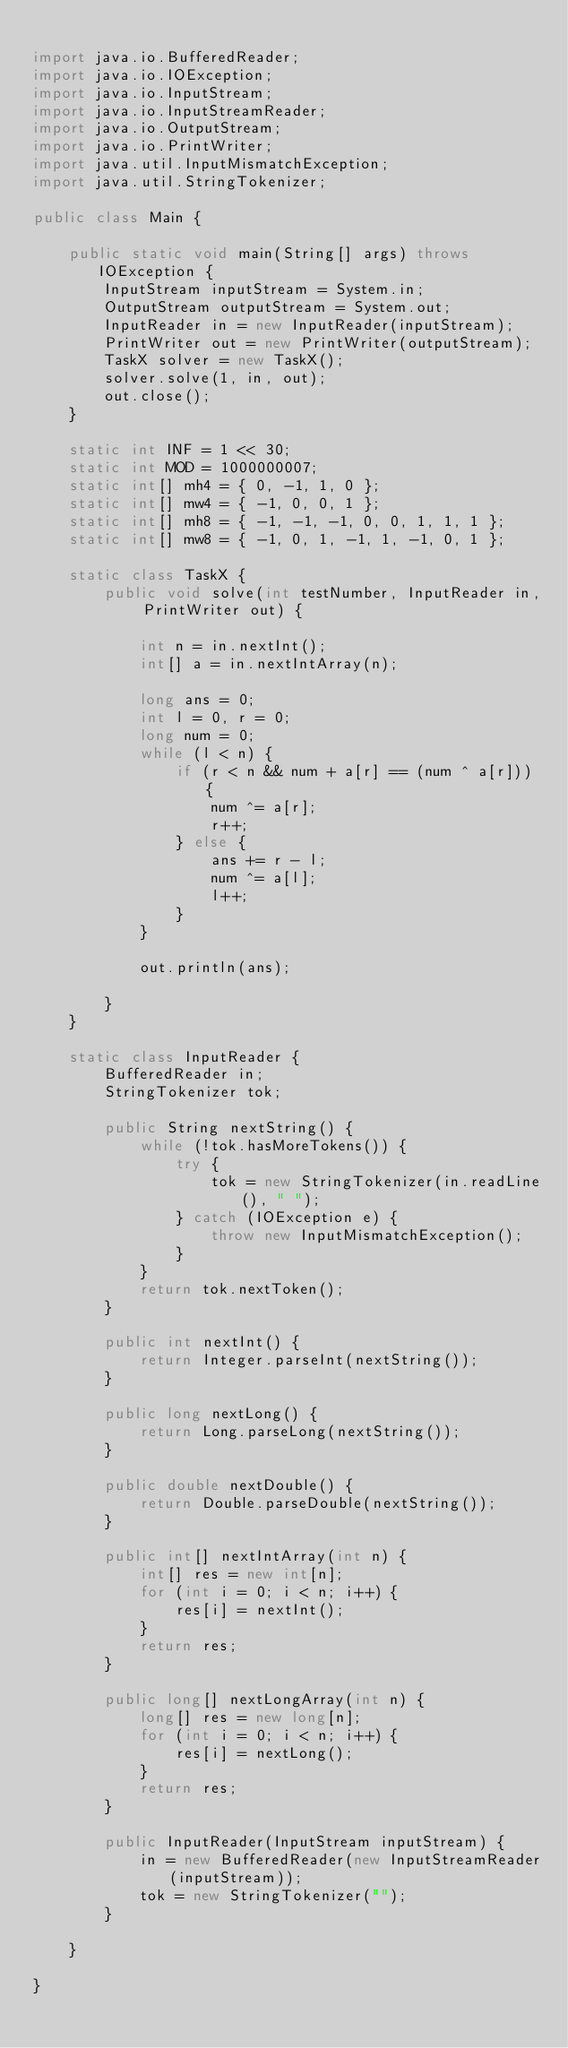<code> <loc_0><loc_0><loc_500><loc_500><_Java_>
import java.io.BufferedReader;
import java.io.IOException;
import java.io.InputStream;
import java.io.InputStreamReader;
import java.io.OutputStream;
import java.io.PrintWriter;
import java.util.InputMismatchException;
import java.util.StringTokenizer;

public class Main {

	public static void main(String[] args) throws IOException {
		InputStream inputStream = System.in;
		OutputStream outputStream = System.out;
		InputReader in = new InputReader(inputStream);
		PrintWriter out = new PrintWriter(outputStream);
		TaskX solver = new TaskX();
		solver.solve(1, in, out);
		out.close();
	}

	static int INF = 1 << 30;
	static int MOD = 1000000007;
	static int[] mh4 = { 0, -1, 1, 0 };
	static int[] mw4 = { -1, 0, 0, 1 };
	static int[] mh8 = { -1, -1, -1, 0, 0, 1, 1, 1 };
	static int[] mw8 = { -1, 0, 1, -1, 1, -1, 0, 1 };

	static class TaskX {
		public void solve(int testNumber, InputReader in, PrintWriter out) {

			int n = in.nextInt();
			int[] a = in.nextIntArray(n);

			long ans = 0;
			int l = 0, r = 0;
			long num = 0;
			while (l < n) {
				if (r < n && num + a[r] == (num ^ a[r])) {
					num ^= a[r];
					r++;
				} else {
					ans += r - l;
					num ^= a[l];
					l++;
				}
			}

			out.println(ans);

		}
	}

	static class InputReader {
		BufferedReader in;
		StringTokenizer tok;

		public String nextString() {
			while (!tok.hasMoreTokens()) {
				try {
					tok = new StringTokenizer(in.readLine(), " ");
				} catch (IOException e) {
					throw new InputMismatchException();
				}
			}
			return tok.nextToken();
		}

		public int nextInt() {
			return Integer.parseInt(nextString());
		}

		public long nextLong() {
			return Long.parseLong(nextString());
		}

		public double nextDouble() {
			return Double.parseDouble(nextString());
		}

		public int[] nextIntArray(int n) {
			int[] res = new int[n];
			for (int i = 0; i < n; i++) {
				res[i] = nextInt();
			}
			return res;
		}

		public long[] nextLongArray(int n) {
			long[] res = new long[n];
			for (int i = 0; i < n; i++) {
				res[i] = nextLong();
			}
			return res;
		}

		public InputReader(InputStream inputStream) {
			in = new BufferedReader(new InputStreamReader(inputStream));
			tok = new StringTokenizer("");
		}

	}

}
</code> 